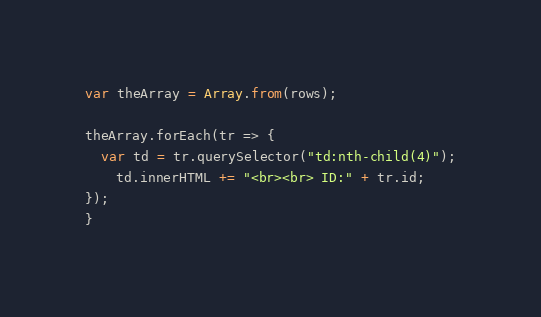Convert code to text. <code><loc_0><loc_0><loc_500><loc_500><_JavaScript_>var theArray = Array.from(rows);

theArray.forEach(tr => {
  var td = tr.querySelector("td:nth-child(4)");
    td.innerHTML += "<br><br> ID:" + tr.id;
});
}
</code> 